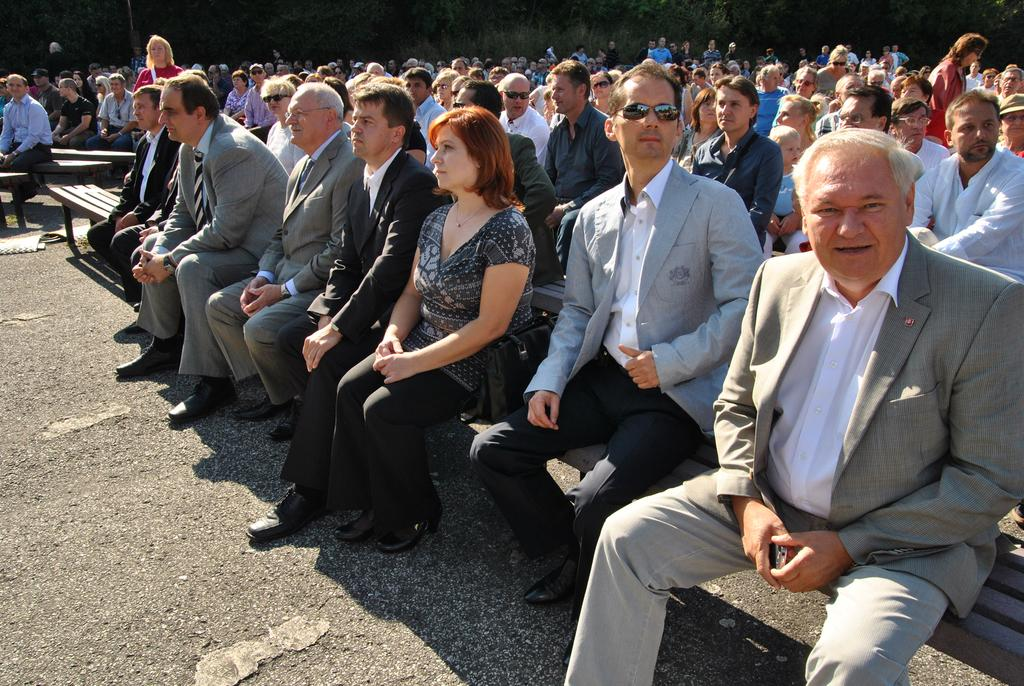What are the people in the image doing? The people in the image are sitting on benches and standing on the ground. What can be seen in the background of the image? There are trees in the background of the image. What is the price of the jeans worn by the people in the image? There is no information about jeans or their prices in the image. 